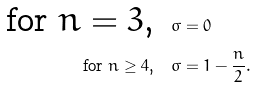<formula> <loc_0><loc_0><loc_500><loc_500>\ \text {for $n=3$,} & \quad \sigma = 0 \\ \ \text {for $n\geq4$,} & \quad \sigma = 1 - \frac { n } { 2 } .</formula> 